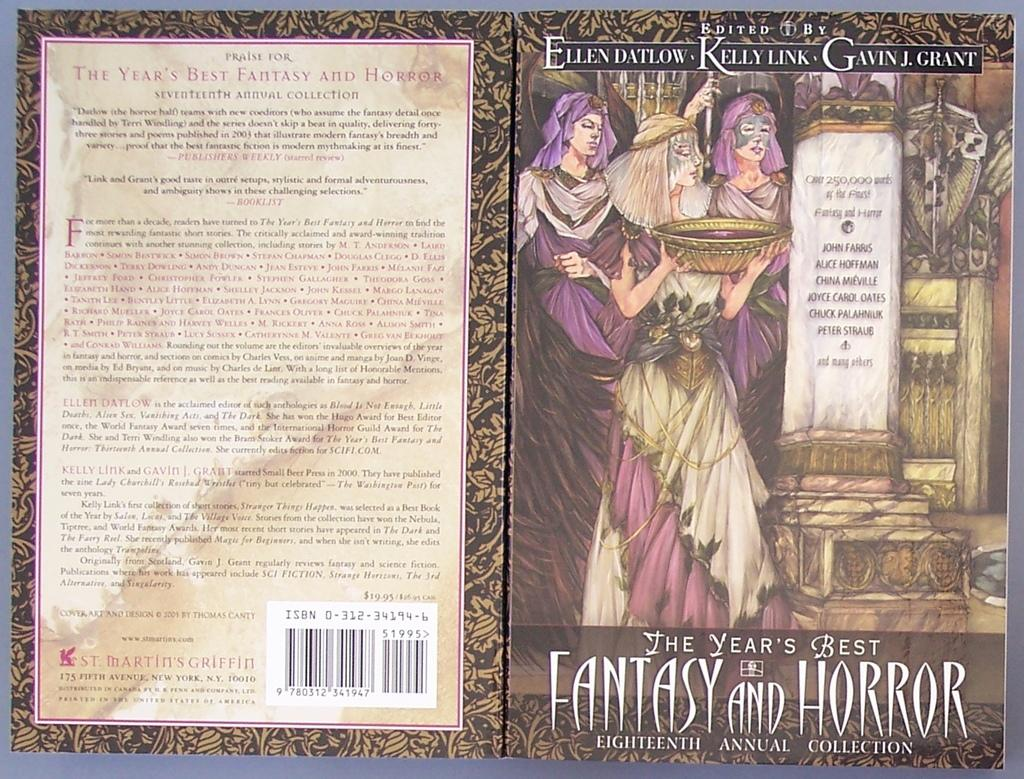Provide a one-sentence caption for the provided image. A collection of 'the year's best fantasty and horror'. 